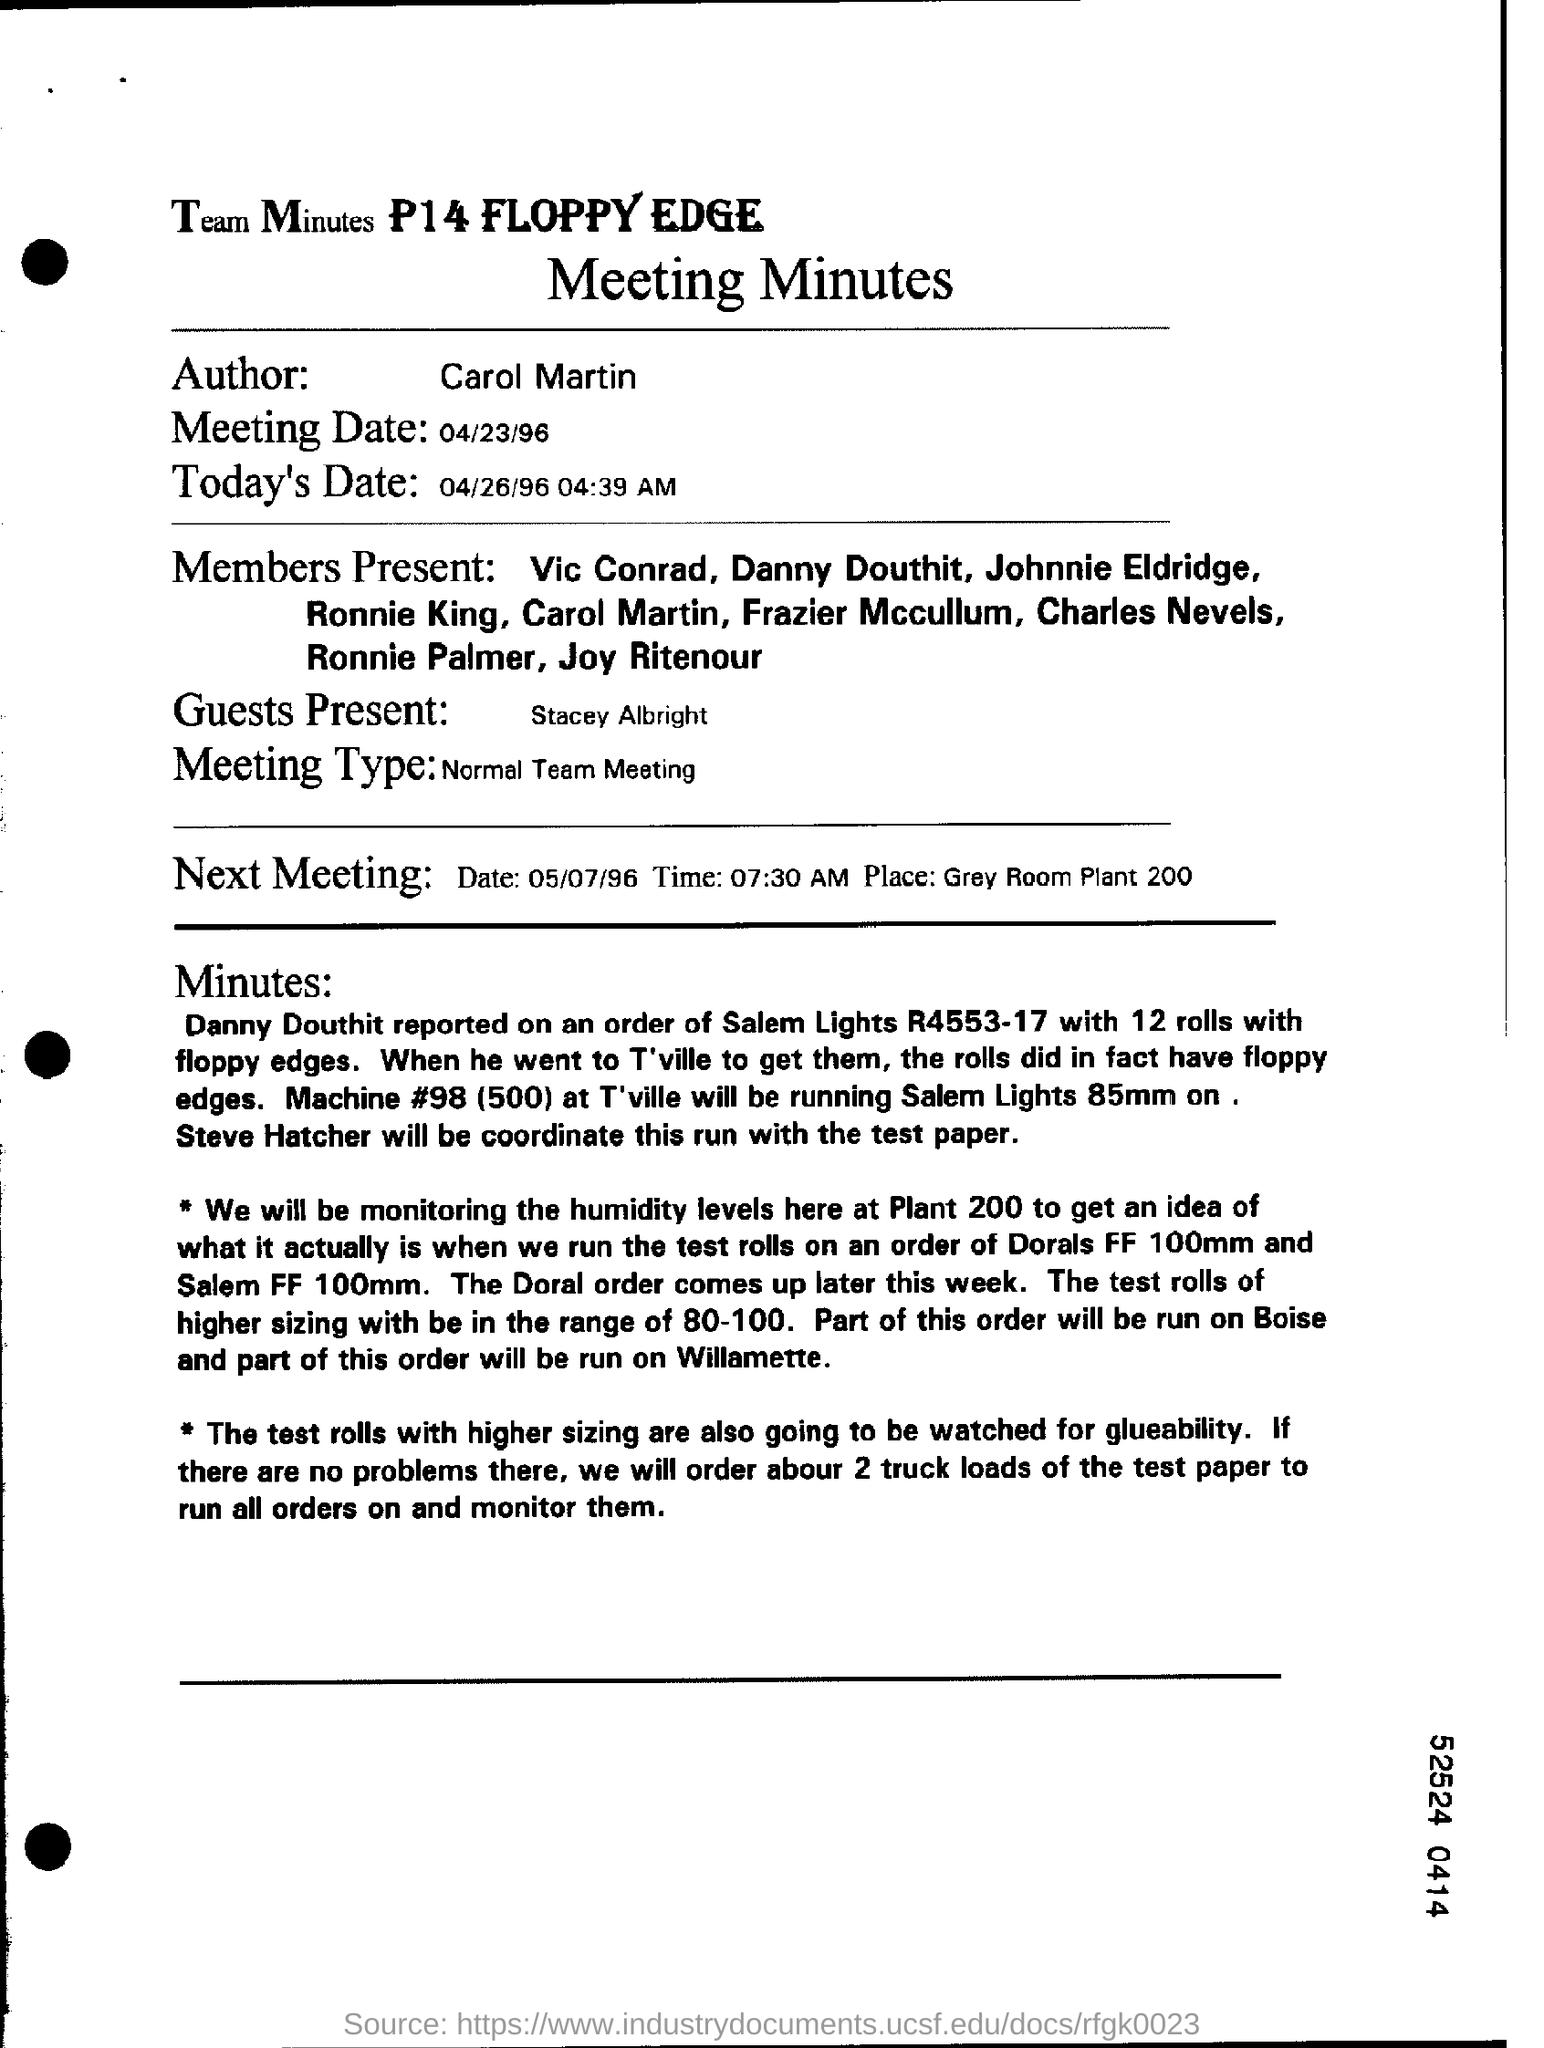What is the name of the author?
Your response must be concise. Carol Martin. What is the meeting date mention in the document?
Keep it short and to the point. 04/23/96. What is todays date in the document?
Provide a succinct answer. 04/26/96 04:39 AM. Name the guests present in the document?
Ensure brevity in your answer.  Stacey Albright. What is meeting type ?
Keep it short and to the point. Normal Team Meeting. 